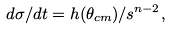<formula> <loc_0><loc_0><loc_500><loc_500>d \sigma / d t = h ( \theta _ { c m } ) / s ^ { n - 2 } ,</formula> 